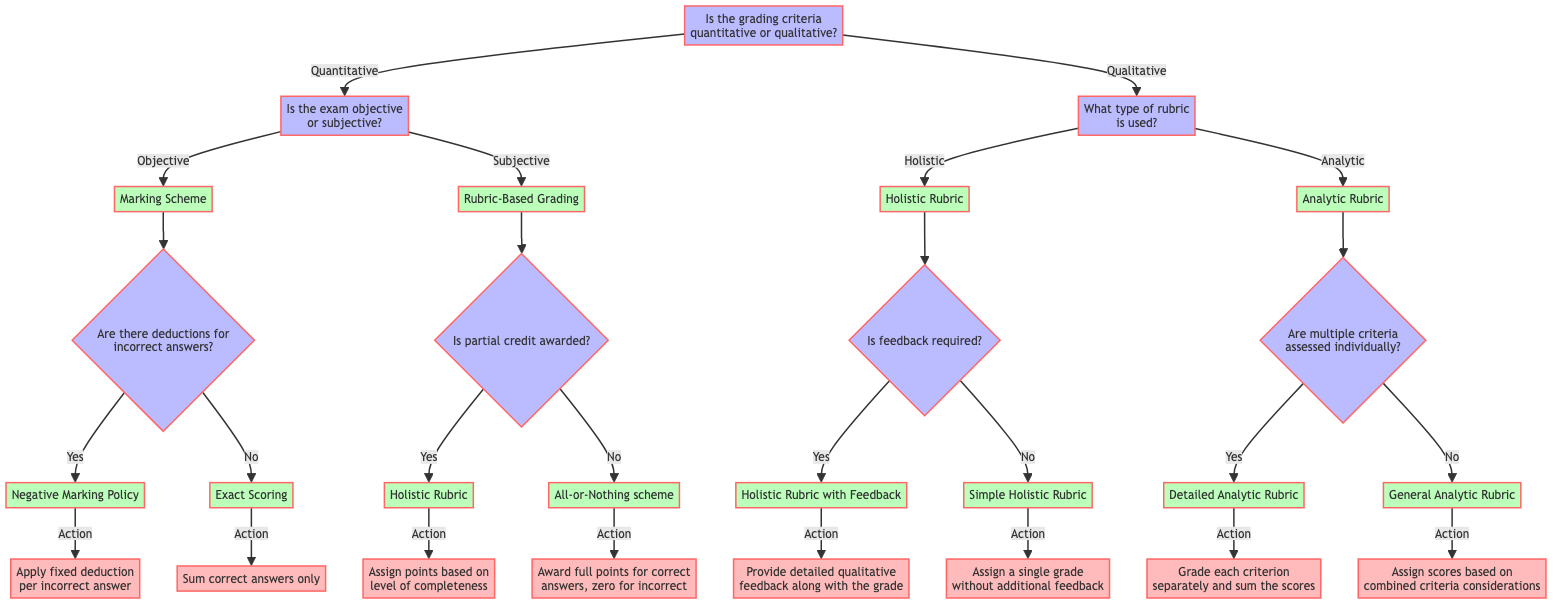What are the two main categories of grading criteria? The diagram starts with a root question that asks whether the grading criteria is quantitative or qualitative, which are the two main categories.
Answer: Quantitative, Qualitative Which type of exam does the 'Marking Scheme' category refer to? Following the flow from the root node, the query "Is the exam objective or subjective?" leads to the 'Marking Scheme', which is under the category of objective exams.
Answer: Objective What action is specified for 'Negative Marking Policy'? Under 'Marking Scheme', if deductions for incorrect answers are yes, the action specified is to apply a fixed deduction per incorrect answer.
Answer: Apply fixed deduction per incorrect answer What is the action taken if 'partial credit is awarded'? In the subjective category under 'Rubric-Based Grading', if partial credit is awarded (yes), the action is to assign points based on the level of completeness that corresponds to a holistic rubric.
Answer: Assign points based on level of completeness How many types of rubrics are depicted in the qualitative section? The decision tree distinguishes between two types of rubrics in the qualitative section: holistic and analytic. Thus, we count these to determine the number of types.
Answer: Two What does the 'General Analytic Rubric' action imply? Traversing through the analytic rubric, it specifies that if multiple criteria are not assessed individually (no), the grading action is to assign scores based on combined criteria considerations.
Answer: Assign scores based on combined criteria considerations Which criteria allows detailed qualitative feedback along with a grade? Following the path from the holistic rubric, the situation where feedback is required leads to the criteria called 'Holistic Rubric with Feedback', allowing for detailed qualitative feedback.
Answer: Holistic Rubric with Feedback What does the 'All-or-Nothing scheme' action indicate? In the flow of the subjective section under 'Rubric-Based Grading', if partial credit is not awarded (no), the corresponding action indicates that full points are awarded for correct answers, while zero is given for incorrect.
Answer: Award full points for correct answers, zero for incorrect What is the relationship between 'Detailed Analytic Rubric' and individual assessment? The path from the analytic rubric directly associates 'Detailed Analytic Rubric' with the condition where multiple criteria are assessed individually answered yes. Thus, it indicates a direct correlation with specific assessment.
Answer: Assess each criterion separately 